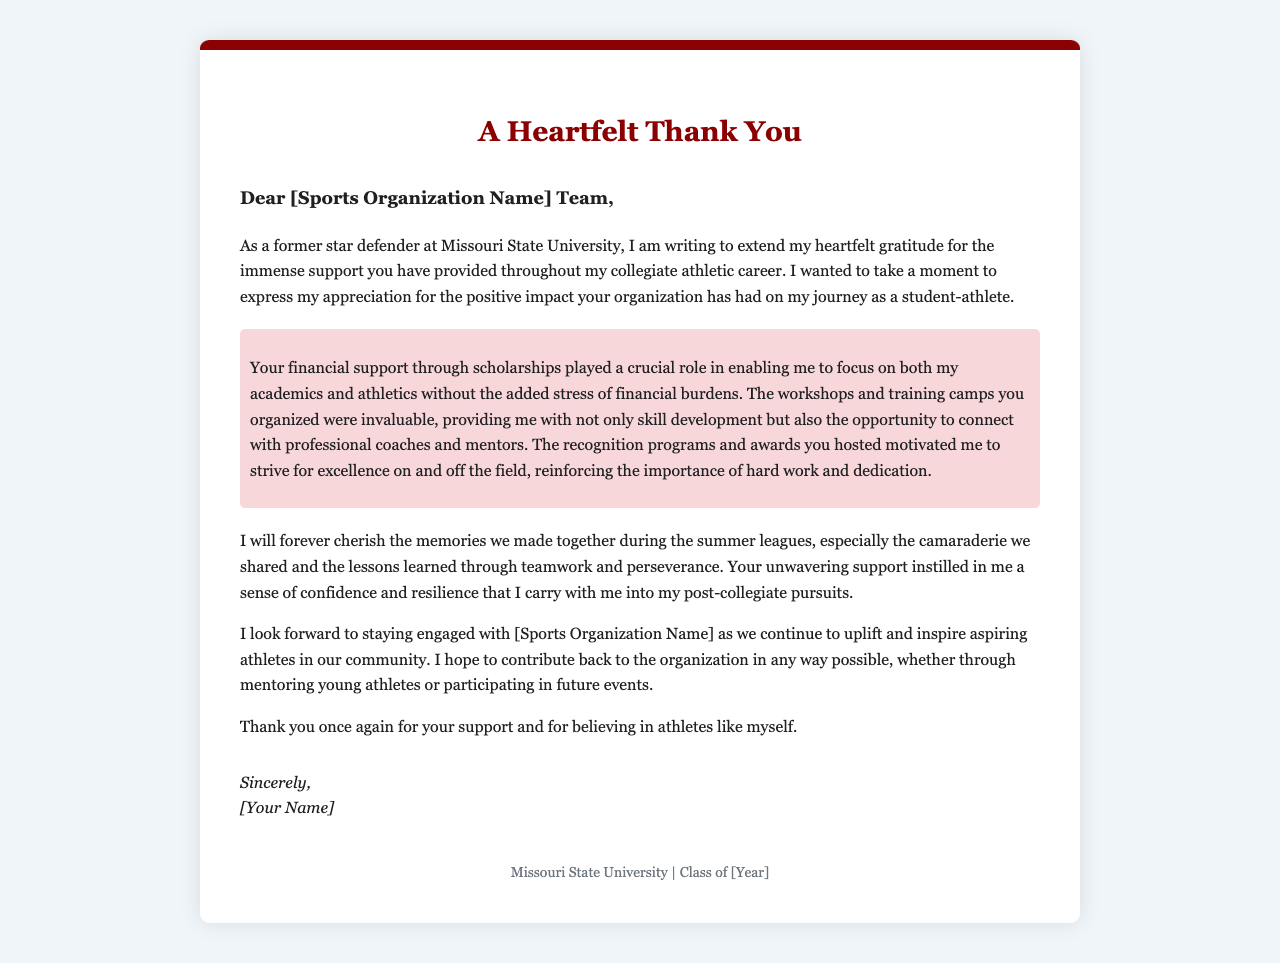What is the title of the letter? The title is prominently displayed at the top of the document, indicating the overall theme of gratitude.
Answer: A Heartfelt Thank You Who is the letter addressed to? The greeting section of the letter indicates the recipient, referring to the organization.
Answer: [Sports Organization Name] Team What role did financial support play according to the letter? The letter notes the significance of scholarships in alleviating the financial load, allowing focus on studies and sports.
Answer: Crucial role What qualities did the organization instill in the writer? The letter mentions the personal growth and attributes developed through support received from the organization.
Answer: Confidence and resilience What classes is the writer associated with? The footer of the letter provides the academic institution and graduation year associated with the writer.
Answer: Class of [Year] 